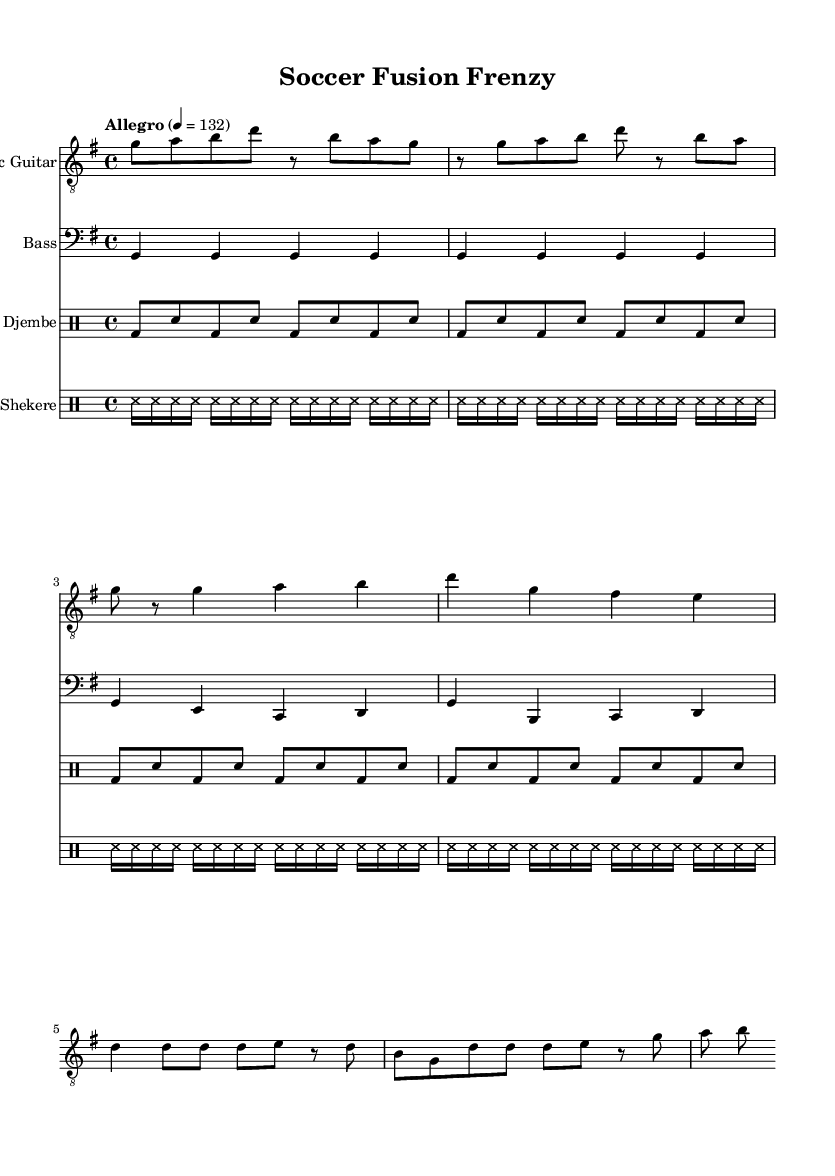What is the key signature of this music? The key signature is indicated at the beginning of the staff and shows a single sharp, which corresponds to the key of G major.
Answer: G major What is the time signature of this music? The time signature is located at the beginning of the sheet music next to the key signature. It shows 4/4, which indicates four beats per measure.
Answer: 4/4 What is the tempo marking for this piece? The tempo marking "Allegro" is found near the top of the music, with a metronome marking of 132 beats per minute, indicating a fast pace.
Answer: Allegro, 132 How many measures are in the electric guitar part? By counting the individual groups separated by bar lines in the electric guitar staff, we find there are eight measures in total.
Answer: 8 How many times does the bass part repeat its motif? The bass part clearly shows that the first four measures repeat again in the subsequent four measures, so it repeats once.
Answer: 1 What rhythmic pattern is used by the djembe? The djembe employs a consistent pattern of bass and snare notes throughout, evident from the repeated sequences in the drummode staff.
Answer: Bass and snare What type of percussion instrument is indicated in the shekere part? The shekere section is labeled as a "DrumStaff" which uses the notation ss, representing the shekere's unique sound in the rhythm.
Answer: Shekere 